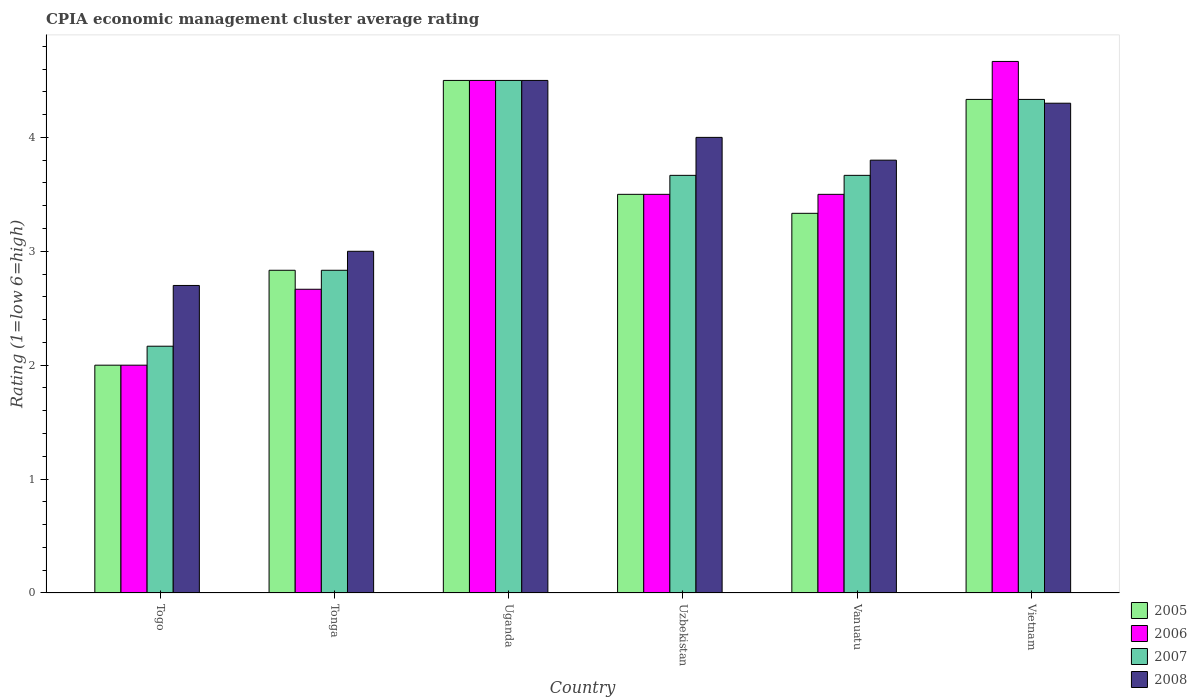Are the number of bars on each tick of the X-axis equal?
Your response must be concise. Yes. How many bars are there on the 5th tick from the left?
Provide a short and direct response. 4. What is the label of the 1st group of bars from the left?
Provide a succinct answer. Togo. What is the CPIA rating in 2005 in Tonga?
Offer a terse response. 2.83. Across all countries, what is the maximum CPIA rating in 2005?
Your answer should be very brief. 4.5. Across all countries, what is the minimum CPIA rating in 2007?
Offer a very short reply. 2.17. In which country was the CPIA rating in 2007 maximum?
Keep it short and to the point. Uganda. In which country was the CPIA rating in 2007 minimum?
Offer a terse response. Togo. What is the total CPIA rating in 2008 in the graph?
Ensure brevity in your answer.  22.3. What is the average CPIA rating in 2007 per country?
Provide a short and direct response. 3.53. What is the difference between the CPIA rating of/in 2005 and CPIA rating of/in 2006 in Uzbekistan?
Offer a very short reply. 0. In how many countries, is the CPIA rating in 2006 greater than 2.8?
Your response must be concise. 4. What is the ratio of the CPIA rating in 2008 in Uganda to that in Vanuatu?
Offer a terse response. 1.18. Is the CPIA rating in 2005 in Tonga less than that in Uganda?
Keep it short and to the point. Yes. What does the 4th bar from the left in Tonga represents?
Offer a very short reply. 2008. How many bars are there?
Offer a very short reply. 24. Are all the bars in the graph horizontal?
Provide a succinct answer. No. How many countries are there in the graph?
Offer a terse response. 6. What is the difference between two consecutive major ticks on the Y-axis?
Your answer should be compact. 1. Are the values on the major ticks of Y-axis written in scientific E-notation?
Your answer should be compact. No. Does the graph contain any zero values?
Provide a succinct answer. No. Does the graph contain grids?
Keep it short and to the point. No. Where does the legend appear in the graph?
Your response must be concise. Bottom right. How are the legend labels stacked?
Your response must be concise. Vertical. What is the title of the graph?
Offer a terse response. CPIA economic management cluster average rating. Does "1965" appear as one of the legend labels in the graph?
Make the answer very short. No. What is the Rating (1=low 6=high) of 2005 in Togo?
Make the answer very short. 2. What is the Rating (1=low 6=high) in 2007 in Togo?
Your response must be concise. 2.17. What is the Rating (1=low 6=high) of 2008 in Togo?
Your answer should be compact. 2.7. What is the Rating (1=low 6=high) of 2005 in Tonga?
Your response must be concise. 2.83. What is the Rating (1=low 6=high) in 2006 in Tonga?
Provide a succinct answer. 2.67. What is the Rating (1=low 6=high) of 2007 in Tonga?
Your response must be concise. 2.83. What is the Rating (1=low 6=high) of 2007 in Uzbekistan?
Keep it short and to the point. 3.67. What is the Rating (1=low 6=high) of 2005 in Vanuatu?
Keep it short and to the point. 3.33. What is the Rating (1=low 6=high) in 2007 in Vanuatu?
Provide a succinct answer. 3.67. What is the Rating (1=low 6=high) of 2005 in Vietnam?
Your answer should be compact. 4.33. What is the Rating (1=low 6=high) of 2006 in Vietnam?
Provide a succinct answer. 4.67. What is the Rating (1=low 6=high) of 2007 in Vietnam?
Offer a very short reply. 4.33. Across all countries, what is the maximum Rating (1=low 6=high) of 2005?
Ensure brevity in your answer.  4.5. Across all countries, what is the maximum Rating (1=low 6=high) of 2006?
Ensure brevity in your answer.  4.67. Across all countries, what is the maximum Rating (1=low 6=high) in 2007?
Make the answer very short. 4.5. Across all countries, what is the maximum Rating (1=low 6=high) in 2008?
Your answer should be compact. 4.5. Across all countries, what is the minimum Rating (1=low 6=high) of 2007?
Your response must be concise. 2.17. Across all countries, what is the minimum Rating (1=low 6=high) of 2008?
Your response must be concise. 2.7. What is the total Rating (1=low 6=high) in 2006 in the graph?
Your response must be concise. 20.83. What is the total Rating (1=low 6=high) of 2007 in the graph?
Offer a very short reply. 21.17. What is the total Rating (1=low 6=high) of 2008 in the graph?
Your answer should be very brief. 22.3. What is the difference between the Rating (1=low 6=high) in 2007 in Togo and that in Uganda?
Keep it short and to the point. -2.33. What is the difference between the Rating (1=low 6=high) of 2008 in Togo and that in Uganda?
Your answer should be compact. -1.8. What is the difference between the Rating (1=low 6=high) of 2007 in Togo and that in Uzbekistan?
Keep it short and to the point. -1.5. What is the difference between the Rating (1=low 6=high) in 2008 in Togo and that in Uzbekistan?
Give a very brief answer. -1.3. What is the difference between the Rating (1=low 6=high) of 2005 in Togo and that in Vanuatu?
Your answer should be very brief. -1.33. What is the difference between the Rating (1=low 6=high) of 2007 in Togo and that in Vanuatu?
Give a very brief answer. -1.5. What is the difference between the Rating (1=low 6=high) in 2005 in Togo and that in Vietnam?
Offer a terse response. -2.33. What is the difference between the Rating (1=low 6=high) of 2006 in Togo and that in Vietnam?
Provide a short and direct response. -2.67. What is the difference between the Rating (1=low 6=high) of 2007 in Togo and that in Vietnam?
Keep it short and to the point. -2.17. What is the difference between the Rating (1=low 6=high) of 2005 in Tonga and that in Uganda?
Give a very brief answer. -1.67. What is the difference between the Rating (1=low 6=high) of 2006 in Tonga and that in Uganda?
Ensure brevity in your answer.  -1.83. What is the difference between the Rating (1=low 6=high) in 2007 in Tonga and that in Uganda?
Offer a terse response. -1.67. What is the difference between the Rating (1=low 6=high) of 2008 in Tonga and that in Uganda?
Make the answer very short. -1.5. What is the difference between the Rating (1=low 6=high) in 2008 in Tonga and that in Uzbekistan?
Provide a short and direct response. -1. What is the difference between the Rating (1=low 6=high) of 2005 in Tonga and that in Vanuatu?
Offer a very short reply. -0.5. What is the difference between the Rating (1=low 6=high) in 2008 in Tonga and that in Vanuatu?
Provide a short and direct response. -0.8. What is the difference between the Rating (1=low 6=high) of 2005 in Tonga and that in Vietnam?
Ensure brevity in your answer.  -1.5. What is the difference between the Rating (1=low 6=high) of 2006 in Tonga and that in Vietnam?
Your response must be concise. -2. What is the difference between the Rating (1=low 6=high) in 2007 in Tonga and that in Vietnam?
Provide a succinct answer. -1.5. What is the difference between the Rating (1=low 6=high) of 2008 in Tonga and that in Vietnam?
Your answer should be very brief. -1.3. What is the difference between the Rating (1=low 6=high) of 2005 in Uganda and that in Uzbekistan?
Your response must be concise. 1. What is the difference between the Rating (1=low 6=high) in 2007 in Uganda and that in Uzbekistan?
Offer a very short reply. 0.83. What is the difference between the Rating (1=low 6=high) in 2008 in Uganda and that in Uzbekistan?
Ensure brevity in your answer.  0.5. What is the difference between the Rating (1=low 6=high) of 2006 in Uganda and that in Vanuatu?
Make the answer very short. 1. What is the difference between the Rating (1=low 6=high) of 2005 in Uganda and that in Vietnam?
Provide a short and direct response. 0.17. What is the difference between the Rating (1=low 6=high) of 2007 in Uganda and that in Vietnam?
Make the answer very short. 0.17. What is the difference between the Rating (1=low 6=high) of 2008 in Uganda and that in Vietnam?
Provide a short and direct response. 0.2. What is the difference between the Rating (1=low 6=high) in 2005 in Uzbekistan and that in Vanuatu?
Give a very brief answer. 0.17. What is the difference between the Rating (1=low 6=high) of 2006 in Uzbekistan and that in Vanuatu?
Ensure brevity in your answer.  0. What is the difference between the Rating (1=low 6=high) of 2007 in Uzbekistan and that in Vanuatu?
Provide a succinct answer. 0. What is the difference between the Rating (1=low 6=high) of 2008 in Uzbekistan and that in Vanuatu?
Ensure brevity in your answer.  0.2. What is the difference between the Rating (1=low 6=high) of 2005 in Uzbekistan and that in Vietnam?
Your answer should be compact. -0.83. What is the difference between the Rating (1=low 6=high) in 2006 in Uzbekistan and that in Vietnam?
Provide a short and direct response. -1.17. What is the difference between the Rating (1=low 6=high) of 2006 in Vanuatu and that in Vietnam?
Ensure brevity in your answer.  -1.17. What is the difference between the Rating (1=low 6=high) of 2005 in Togo and the Rating (1=low 6=high) of 2006 in Tonga?
Ensure brevity in your answer.  -0.67. What is the difference between the Rating (1=low 6=high) in 2005 in Togo and the Rating (1=low 6=high) in 2008 in Tonga?
Make the answer very short. -1. What is the difference between the Rating (1=low 6=high) of 2006 in Togo and the Rating (1=low 6=high) of 2008 in Tonga?
Provide a short and direct response. -1. What is the difference between the Rating (1=low 6=high) of 2007 in Togo and the Rating (1=low 6=high) of 2008 in Tonga?
Give a very brief answer. -0.83. What is the difference between the Rating (1=low 6=high) in 2005 in Togo and the Rating (1=low 6=high) in 2006 in Uganda?
Offer a terse response. -2.5. What is the difference between the Rating (1=low 6=high) in 2006 in Togo and the Rating (1=low 6=high) in 2007 in Uganda?
Offer a terse response. -2.5. What is the difference between the Rating (1=low 6=high) in 2006 in Togo and the Rating (1=low 6=high) in 2008 in Uganda?
Give a very brief answer. -2.5. What is the difference between the Rating (1=low 6=high) in 2007 in Togo and the Rating (1=low 6=high) in 2008 in Uganda?
Your answer should be compact. -2.33. What is the difference between the Rating (1=low 6=high) in 2005 in Togo and the Rating (1=low 6=high) in 2007 in Uzbekistan?
Your answer should be compact. -1.67. What is the difference between the Rating (1=low 6=high) in 2005 in Togo and the Rating (1=low 6=high) in 2008 in Uzbekistan?
Provide a short and direct response. -2. What is the difference between the Rating (1=low 6=high) in 2006 in Togo and the Rating (1=low 6=high) in 2007 in Uzbekistan?
Ensure brevity in your answer.  -1.67. What is the difference between the Rating (1=low 6=high) in 2006 in Togo and the Rating (1=low 6=high) in 2008 in Uzbekistan?
Your answer should be very brief. -2. What is the difference between the Rating (1=low 6=high) of 2007 in Togo and the Rating (1=low 6=high) of 2008 in Uzbekistan?
Offer a very short reply. -1.83. What is the difference between the Rating (1=low 6=high) of 2005 in Togo and the Rating (1=low 6=high) of 2007 in Vanuatu?
Make the answer very short. -1.67. What is the difference between the Rating (1=low 6=high) in 2005 in Togo and the Rating (1=low 6=high) in 2008 in Vanuatu?
Give a very brief answer. -1.8. What is the difference between the Rating (1=low 6=high) of 2006 in Togo and the Rating (1=low 6=high) of 2007 in Vanuatu?
Your response must be concise. -1.67. What is the difference between the Rating (1=low 6=high) in 2006 in Togo and the Rating (1=low 6=high) in 2008 in Vanuatu?
Give a very brief answer. -1.8. What is the difference between the Rating (1=low 6=high) of 2007 in Togo and the Rating (1=low 6=high) of 2008 in Vanuatu?
Give a very brief answer. -1.63. What is the difference between the Rating (1=low 6=high) in 2005 in Togo and the Rating (1=low 6=high) in 2006 in Vietnam?
Make the answer very short. -2.67. What is the difference between the Rating (1=low 6=high) of 2005 in Togo and the Rating (1=low 6=high) of 2007 in Vietnam?
Provide a succinct answer. -2.33. What is the difference between the Rating (1=low 6=high) in 2005 in Togo and the Rating (1=low 6=high) in 2008 in Vietnam?
Your answer should be very brief. -2.3. What is the difference between the Rating (1=low 6=high) in 2006 in Togo and the Rating (1=low 6=high) in 2007 in Vietnam?
Keep it short and to the point. -2.33. What is the difference between the Rating (1=low 6=high) of 2007 in Togo and the Rating (1=low 6=high) of 2008 in Vietnam?
Provide a succinct answer. -2.13. What is the difference between the Rating (1=low 6=high) in 2005 in Tonga and the Rating (1=low 6=high) in 2006 in Uganda?
Your answer should be compact. -1.67. What is the difference between the Rating (1=low 6=high) of 2005 in Tonga and the Rating (1=low 6=high) of 2007 in Uganda?
Give a very brief answer. -1.67. What is the difference between the Rating (1=low 6=high) in 2005 in Tonga and the Rating (1=low 6=high) in 2008 in Uganda?
Keep it short and to the point. -1.67. What is the difference between the Rating (1=low 6=high) of 2006 in Tonga and the Rating (1=low 6=high) of 2007 in Uganda?
Make the answer very short. -1.83. What is the difference between the Rating (1=low 6=high) in 2006 in Tonga and the Rating (1=low 6=high) in 2008 in Uganda?
Provide a succinct answer. -1.83. What is the difference between the Rating (1=low 6=high) of 2007 in Tonga and the Rating (1=low 6=high) of 2008 in Uganda?
Offer a terse response. -1.67. What is the difference between the Rating (1=low 6=high) of 2005 in Tonga and the Rating (1=low 6=high) of 2008 in Uzbekistan?
Give a very brief answer. -1.17. What is the difference between the Rating (1=low 6=high) of 2006 in Tonga and the Rating (1=low 6=high) of 2008 in Uzbekistan?
Ensure brevity in your answer.  -1.33. What is the difference between the Rating (1=low 6=high) of 2007 in Tonga and the Rating (1=low 6=high) of 2008 in Uzbekistan?
Give a very brief answer. -1.17. What is the difference between the Rating (1=low 6=high) of 2005 in Tonga and the Rating (1=low 6=high) of 2007 in Vanuatu?
Ensure brevity in your answer.  -0.83. What is the difference between the Rating (1=low 6=high) in 2005 in Tonga and the Rating (1=low 6=high) in 2008 in Vanuatu?
Offer a very short reply. -0.97. What is the difference between the Rating (1=low 6=high) in 2006 in Tonga and the Rating (1=low 6=high) in 2007 in Vanuatu?
Provide a succinct answer. -1. What is the difference between the Rating (1=low 6=high) of 2006 in Tonga and the Rating (1=low 6=high) of 2008 in Vanuatu?
Offer a terse response. -1.13. What is the difference between the Rating (1=low 6=high) in 2007 in Tonga and the Rating (1=low 6=high) in 2008 in Vanuatu?
Offer a very short reply. -0.97. What is the difference between the Rating (1=low 6=high) of 2005 in Tonga and the Rating (1=low 6=high) of 2006 in Vietnam?
Offer a terse response. -1.83. What is the difference between the Rating (1=low 6=high) of 2005 in Tonga and the Rating (1=low 6=high) of 2007 in Vietnam?
Keep it short and to the point. -1.5. What is the difference between the Rating (1=low 6=high) in 2005 in Tonga and the Rating (1=low 6=high) in 2008 in Vietnam?
Give a very brief answer. -1.47. What is the difference between the Rating (1=low 6=high) of 2006 in Tonga and the Rating (1=low 6=high) of 2007 in Vietnam?
Your response must be concise. -1.67. What is the difference between the Rating (1=low 6=high) in 2006 in Tonga and the Rating (1=low 6=high) in 2008 in Vietnam?
Provide a short and direct response. -1.63. What is the difference between the Rating (1=low 6=high) of 2007 in Tonga and the Rating (1=low 6=high) of 2008 in Vietnam?
Offer a terse response. -1.47. What is the difference between the Rating (1=low 6=high) in 2006 in Uganda and the Rating (1=low 6=high) in 2007 in Uzbekistan?
Provide a short and direct response. 0.83. What is the difference between the Rating (1=low 6=high) of 2007 in Uganda and the Rating (1=low 6=high) of 2008 in Uzbekistan?
Keep it short and to the point. 0.5. What is the difference between the Rating (1=low 6=high) of 2005 in Uganda and the Rating (1=low 6=high) of 2006 in Vanuatu?
Offer a terse response. 1. What is the difference between the Rating (1=low 6=high) of 2006 in Uganda and the Rating (1=low 6=high) of 2008 in Vietnam?
Ensure brevity in your answer.  0.2. What is the difference between the Rating (1=low 6=high) of 2005 in Uzbekistan and the Rating (1=low 6=high) of 2006 in Vanuatu?
Offer a terse response. 0. What is the difference between the Rating (1=low 6=high) in 2006 in Uzbekistan and the Rating (1=low 6=high) in 2008 in Vanuatu?
Your answer should be very brief. -0.3. What is the difference between the Rating (1=low 6=high) of 2007 in Uzbekistan and the Rating (1=low 6=high) of 2008 in Vanuatu?
Offer a terse response. -0.13. What is the difference between the Rating (1=low 6=high) in 2005 in Uzbekistan and the Rating (1=low 6=high) in 2006 in Vietnam?
Offer a terse response. -1.17. What is the difference between the Rating (1=low 6=high) in 2005 in Uzbekistan and the Rating (1=low 6=high) in 2007 in Vietnam?
Your answer should be compact. -0.83. What is the difference between the Rating (1=low 6=high) of 2005 in Uzbekistan and the Rating (1=low 6=high) of 2008 in Vietnam?
Offer a terse response. -0.8. What is the difference between the Rating (1=low 6=high) in 2006 in Uzbekistan and the Rating (1=low 6=high) in 2007 in Vietnam?
Make the answer very short. -0.83. What is the difference between the Rating (1=low 6=high) of 2006 in Uzbekistan and the Rating (1=low 6=high) of 2008 in Vietnam?
Offer a terse response. -0.8. What is the difference between the Rating (1=low 6=high) of 2007 in Uzbekistan and the Rating (1=low 6=high) of 2008 in Vietnam?
Give a very brief answer. -0.63. What is the difference between the Rating (1=low 6=high) of 2005 in Vanuatu and the Rating (1=low 6=high) of 2006 in Vietnam?
Offer a terse response. -1.33. What is the difference between the Rating (1=low 6=high) of 2005 in Vanuatu and the Rating (1=low 6=high) of 2008 in Vietnam?
Offer a terse response. -0.97. What is the difference between the Rating (1=low 6=high) in 2006 in Vanuatu and the Rating (1=low 6=high) in 2007 in Vietnam?
Your response must be concise. -0.83. What is the difference between the Rating (1=low 6=high) of 2006 in Vanuatu and the Rating (1=low 6=high) of 2008 in Vietnam?
Make the answer very short. -0.8. What is the difference between the Rating (1=low 6=high) of 2007 in Vanuatu and the Rating (1=low 6=high) of 2008 in Vietnam?
Provide a succinct answer. -0.63. What is the average Rating (1=low 6=high) in 2005 per country?
Keep it short and to the point. 3.42. What is the average Rating (1=low 6=high) in 2006 per country?
Make the answer very short. 3.47. What is the average Rating (1=low 6=high) in 2007 per country?
Provide a succinct answer. 3.53. What is the average Rating (1=low 6=high) in 2008 per country?
Your response must be concise. 3.72. What is the difference between the Rating (1=low 6=high) of 2005 and Rating (1=low 6=high) of 2006 in Togo?
Provide a short and direct response. 0. What is the difference between the Rating (1=low 6=high) of 2005 and Rating (1=low 6=high) of 2007 in Togo?
Your response must be concise. -0.17. What is the difference between the Rating (1=low 6=high) of 2005 and Rating (1=low 6=high) of 2008 in Togo?
Provide a short and direct response. -0.7. What is the difference between the Rating (1=low 6=high) of 2006 and Rating (1=low 6=high) of 2008 in Togo?
Make the answer very short. -0.7. What is the difference between the Rating (1=low 6=high) in 2007 and Rating (1=low 6=high) in 2008 in Togo?
Give a very brief answer. -0.53. What is the difference between the Rating (1=low 6=high) of 2006 and Rating (1=low 6=high) of 2007 in Tonga?
Ensure brevity in your answer.  -0.17. What is the difference between the Rating (1=low 6=high) of 2006 and Rating (1=low 6=high) of 2007 in Uganda?
Provide a short and direct response. 0. What is the difference between the Rating (1=low 6=high) of 2006 and Rating (1=low 6=high) of 2008 in Uganda?
Provide a short and direct response. 0. What is the difference between the Rating (1=low 6=high) of 2007 and Rating (1=low 6=high) of 2008 in Uganda?
Provide a short and direct response. 0. What is the difference between the Rating (1=low 6=high) in 2005 and Rating (1=low 6=high) in 2006 in Uzbekistan?
Provide a succinct answer. 0. What is the difference between the Rating (1=low 6=high) of 2005 and Rating (1=low 6=high) of 2007 in Uzbekistan?
Give a very brief answer. -0.17. What is the difference between the Rating (1=low 6=high) in 2007 and Rating (1=low 6=high) in 2008 in Uzbekistan?
Make the answer very short. -0.33. What is the difference between the Rating (1=low 6=high) of 2005 and Rating (1=low 6=high) of 2006 in Vanuatu?
Your answer should be compact. -0.17. What is the difference between the Rating (1=low 6=high) in 2005 and Rating (1=low 6=high) in 2007 in Vanuatu?
Ensure brevity in your answer.  -0.33. What is the difference between the Rating (1=low 6=high) of 2005 and Rating (1=low 6=high) of 2008 in Vanuatu?
Give a very brief answer. -0.47. What is the difference between the Rating (1=low 6=high) of 2007 and Rating (1=low 6=high) of 2008 in Vanuatu?
Give a very brief answer. -0.13. What is the difference between the Rating (1=low 6=high) of 2006 and Rating (1=low 6=high) of 2007 in Vietnam?
Your response must be concise. 0.33. What is the difference between the Rating (1=low 6=high) of 2006 and Rating (1=low 6=high) of 2008 in Vietnam?
Ensure brevity in your answer.  0.37. What is the ratio of the Rating (1=low 6=high) in 2005 in Togo to that in Tonga?
Ensure brevity in your answer.  0.71. What is the ratio of the Rating (1=low 6=high) in 2006 in Togo to that in Tonga?
Your answer should be compact. 0.75. What is the ratio of the Rating (1=low 6=high) in 2007 in Togo to that in Tonga?
Make the answer very short. 0.76. What is the ratio of the Rating (1=low 6=high) of 2005 in Togo to that in Uganda?
Offer a terse response. 0.44. What is the ratio of the Rating (1=low 6=high) in 2006 in Togo to that in Uganda?
Keep it short and to the point. 0.44. What is the ratio of the Rating (1=low 6=high) in 2007 in Togo to that in Uganda?
Your answer should be compact. 0.48. What is the ratio of the Rating (1=low 6=high) of 2005 in Togo to that in Uzbekistan?
Provide a short and direct response. 0.57. What is the ratio of the Rating (1=low 6=high) in 2006 in Togo to that in Uzbekistan?
Make the answer very short. 0.57. What is the ratio of the Rating (1=low 6=high) in 2007 in Togo to that in Uzbekistan?
Provide a short and direct response. 0.59. What is the ratio of the Rating (1=low 6=high) of 2008 in Togo to that in Uzbekistan?
Your response must be concise. 0.68. What is the ratio of the Rating (1=low 6=high) of 2005 in Togo to that in Vanuatu?
Offer a terse response. 0.6. What is the ratio of the Rating (1=low 6=high) of 2006 in Togo to that in Vanuatu?
Provide a succinct answer. 0.57. What is the ratio of the Rating (1=low 6=high) of 2007 in Togo to that in Vanuatu?
Your response must be concise. 0.59. What is the ratio of the Rating (1=low 6=high) in 2008 in Togo to that in Vanuatu?
Offer a terse response. 0.71. What is the ratio of the Rating (1=low 6=high) in 2005 in Togo to that in Vietnam?
Ensure brevity in your answer.  0.46. What is the ratio of the Rating (1=low 6=high) of 2006 in Togo to that in Vietnam?
Ensure brevity in your answer.  0.43. What is the ratio of the Rating (1=low 6=high) in 2007 in Togo to that in Vietnam?
Offer a very short reply. 0.5. What is the ratio of the Rating (1=low 6=high) in 2008 in Togo to that in Vietnam?
Keep it short and to the point. 0.63. What is the ratio of the Rating (1=low 6=high) of 2005 in Tonga to that in Uganda?
Make the answer very short. 0.63. What is the ratio of the Rating (1=low 6=high) in 2006 in Tonga to that in Uganda?
Make the answer very short. 0.59. What is the ratio of the Rating (1=low 6=high) in 2007 in Tonga to that in Uganda?
Your answer should be very brief. 0.63. What is the ratio of the Rating (1=low 6=high) in 2008 in Tonga to that in Uganda?
Your answer should be compact. 0.67. What is the ratio of the Rating (1=low 6=high) in 2005 in Tonga to that in Uzbekistan?
Offer a very short reply. 0.81. What is the ratio of the Rating (1=low 6=high) of 2006 in Tonga to that in Uzbekistan?
Make the answer very short. 0.76. What is the ratio of the Rating (1=low 6=high) of 2007 in Tonga to that in Uzbekistan?
Provide a short and direct response. 0.77. What is the ratio of the Rating (1=low 6=high) in 2008 in Tonga to that in Uzbekistan?
Offer a terse response. 0.75. What is the ratio of the Rating (1=low 6=high) in 2005 in Tonga to that in Vanuatu?
Your answer should be compact. 0.85. What is the ratio of the Rating (1=low 6=high) in 2006 in Tonga to that in Vanuatu?
Make the answer very short. 0.76. What is the ratio of the Rating (1=low 6=high) in 2007 in Tonga to that in Vanuatu?
Ensure brevity in your answer.  0.77. What is the ratio of the Rating (1=low 6=high) in 2008 in Tonga to that in Vanuatu?
Offer a very short reply. 0.79. What is the ratio of the Rating (1=low 6=high) in 2005 in Tonga to that in Vietnam?
Make the answer very short. 0.65. What is the ratio of the Rating (1=low 6=high) in 2006 in Tonga to that in Vietnam?
Your answer should be compact. 0.57. What is the ratio of the Rating (1=low 6=high) of 2007 in Tonga to that in Vietnam?
Keep it short and to the point. 0.65. What is the ratio of the Rating (1=low 6=high) in 2008 in Tonga to that in Vietnam?
Offer a very short reply. 0.7. What is the ratio of the Rating (1=low 6=high) of 2007 in Uganda to that in Uzbekistan?
Offer a terse response. 1.23. What is the ratio of the Rating (1=low 6=high) of 2005 in Uganda to that in Vanuatu?
Your answer should be very brief. 1.35. What is the ratio of the Rating (1=low 6=high) in 2007 in Uganda to that in Vanuatu?
Keep it short and to the point. 1.23. What is the ratio of the Rating (1=low 6=high) in 2008 in Uganda to that in Vanuatu?
Provide a short and direct response. 1.18. What is the ratio of the Rating (1=low 6=high) in 2005 in Uganda to that in Vietnam?
Give a very brief answer. 1.04. What is the ratio of the Rating (1=low 6=high) in 2006 in Uganda to that in Vietnam?
Ensure brevity in your answer.  0.96. What is the ratio of the Rating (1=low 6=high) of 2008 in Uganda to that in Vietnam?
Keep it short and to the point. 1.05. What is the ratio of the Rating (1=low 6=high) of 2006 in Uzbekistan to that in Vanuatu?
Give a very brief answer. 1. What is the ratio of the Rating (1=low 6=high) of 2008 in Uzbekistan to that in Vanuatu?
Keep it short and to the point. 1.05. What is the ratio of the Rating (1=low 6=high) in 2005 in Uzbekistan to that in Vietnam?
Ensure brevity in your answer.  0.81. What is the ratio of the Rating (1=low 6=high) in 2007 in Uzbekistan to that in Vietnam?
Make the answer very short. 0.85. What is the ratio of the Rating (1=low 6=high) of 2008 in Uzbekistan to that in Vietnam?
Provide a short and direct response. 0.93. What is the ratio of the Rating (1=low 6=high) of 2005 in Vanuatu to that in Vietnam?
Your answer should be very brief. 0.77. What is the ratio of the Rating (1=low 6=high) of 2006 in Vanuatu to that in Vietnam?
Your response must be concise. 0.75. What is the ratio of the Rating (1=low 6=high) of 2007 in Vanuatu to that in Vietnam?
Provide a short and direct response. 0.85. What is the ratio of the Rating (1=low 6=high) in 2008 in Vanuatu to that in Vietnam?
Give a very brief answer. 0.88. What is the difference between the highest and the second highest Rating (1=low 6=high) in 2006?
Provide a succinct answer. 0.17. What is the difference between the highest and the second highest Rating (1=low 6=high) in 2008?
Provide a succinct answer. 0.2. What is the difference between the highest and the lowest Rating (1=low 6=high) in 2006?
Offer a very short reply. 2.67. What is the difference between the highest and the lowest Rating (1=low 6=high) of 2007?
Your answer should be compact. 2.33. 